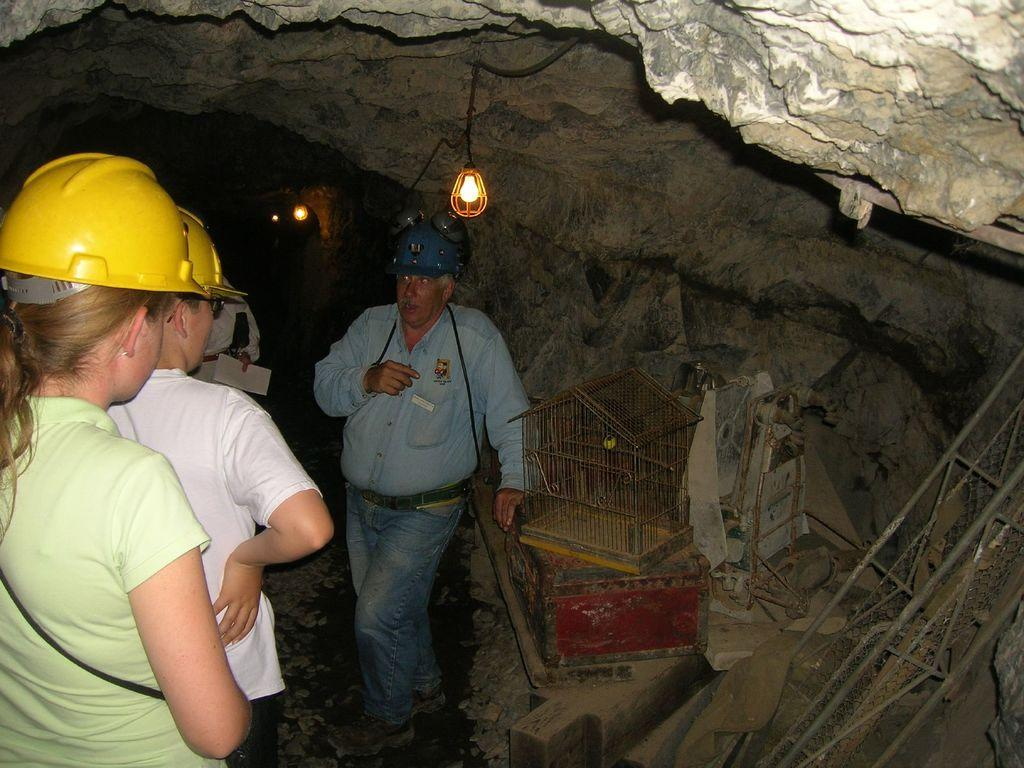Where is the image taken? The image is taken in a cave. What are the people wearing in the image? The people in the image are wearing helmets. What can be seen on the right side of the image? There is a cage on the right side of the image. What are the rods used for in the image? The rods are visible in the image, but their purpose is not specified. What is providing light in the image? There are lights at the top of the image. What type of butter is being used to lubricate the tooth in the image? There is no butter or tooth present in the image; it is taken in a cave with people wearing helmets and a cage on the right side. 